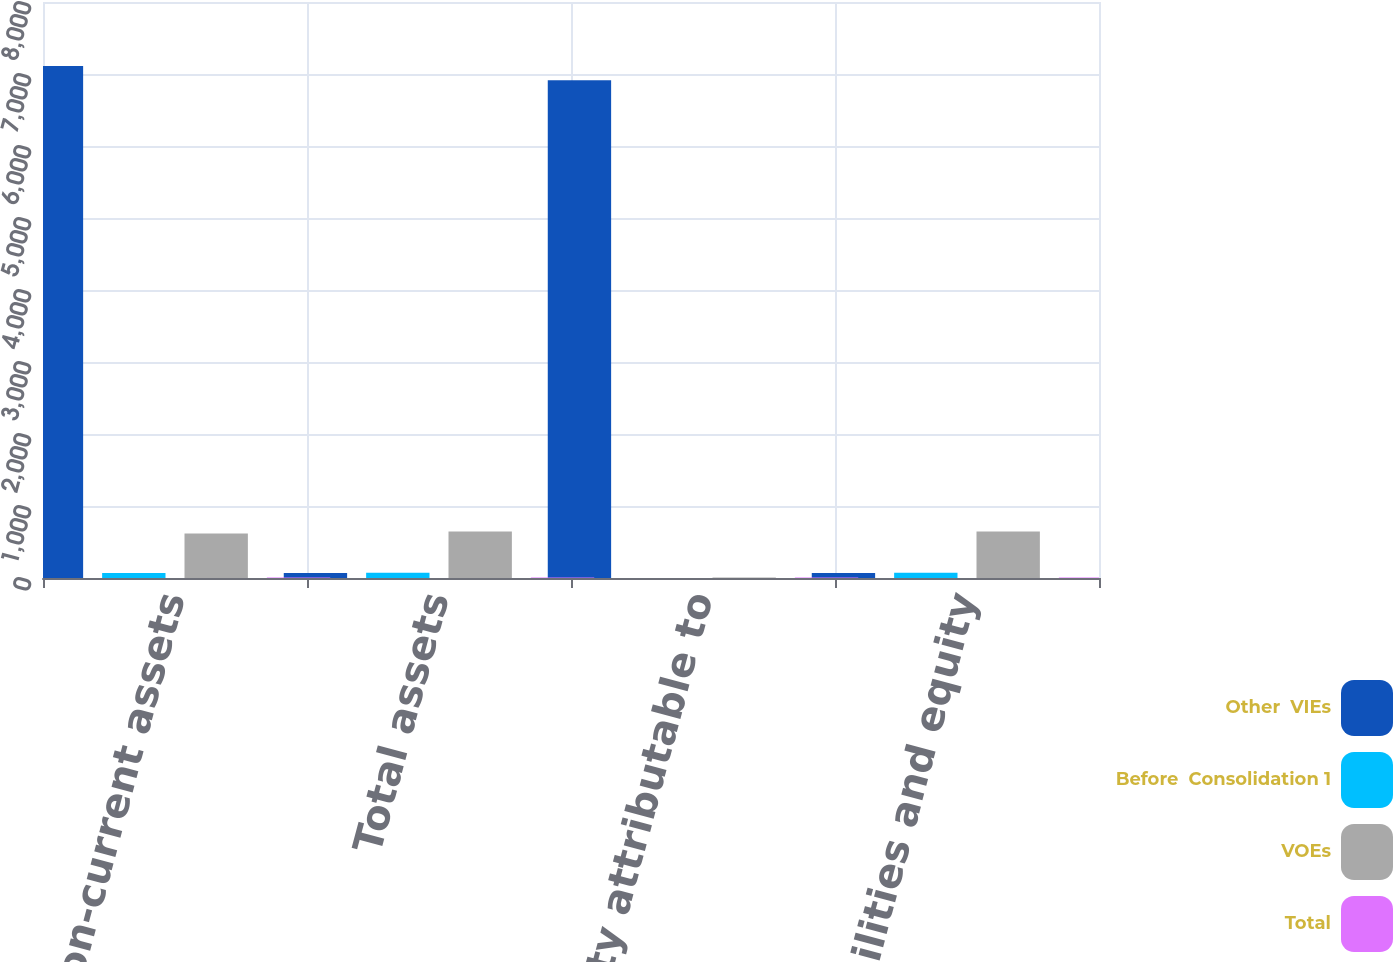Convert chart to OTSL. <chart><loc_0><loc_0><loc_500><loc_500><stacked_bar_chart><ecel><fcel>Non-current assets<fcel>Total assets<fcel>Total equity attributable to<fcel>Total liabilities and equity<nl><fcel>Other  VIEs<fcel>7111.8<fcel>70<fcel>6912.9<fcel>70<nl><fcel>Before  Consolidation 1<fcel>67.9<fcel>72.1<fcel>0.2<fcel>72.1<nl><fcel>VOEs<fcel>617.1<fcel>644.1<fcel>8<fcel>644.1<nl><fcel>Total<fcel>8.2<fcel>8.2<fcel>8.2<fcel>8.2<nl></chart> 